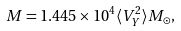Convert formula to latex. <formula><loc_0><loc_0><loc_500><loc_500>M = 1 . 4 4 5 \times 1 0 ^ { 4 } \langle V _ { Y } ^ { 2 } \rangle M _ { \odot } ,</formula> 